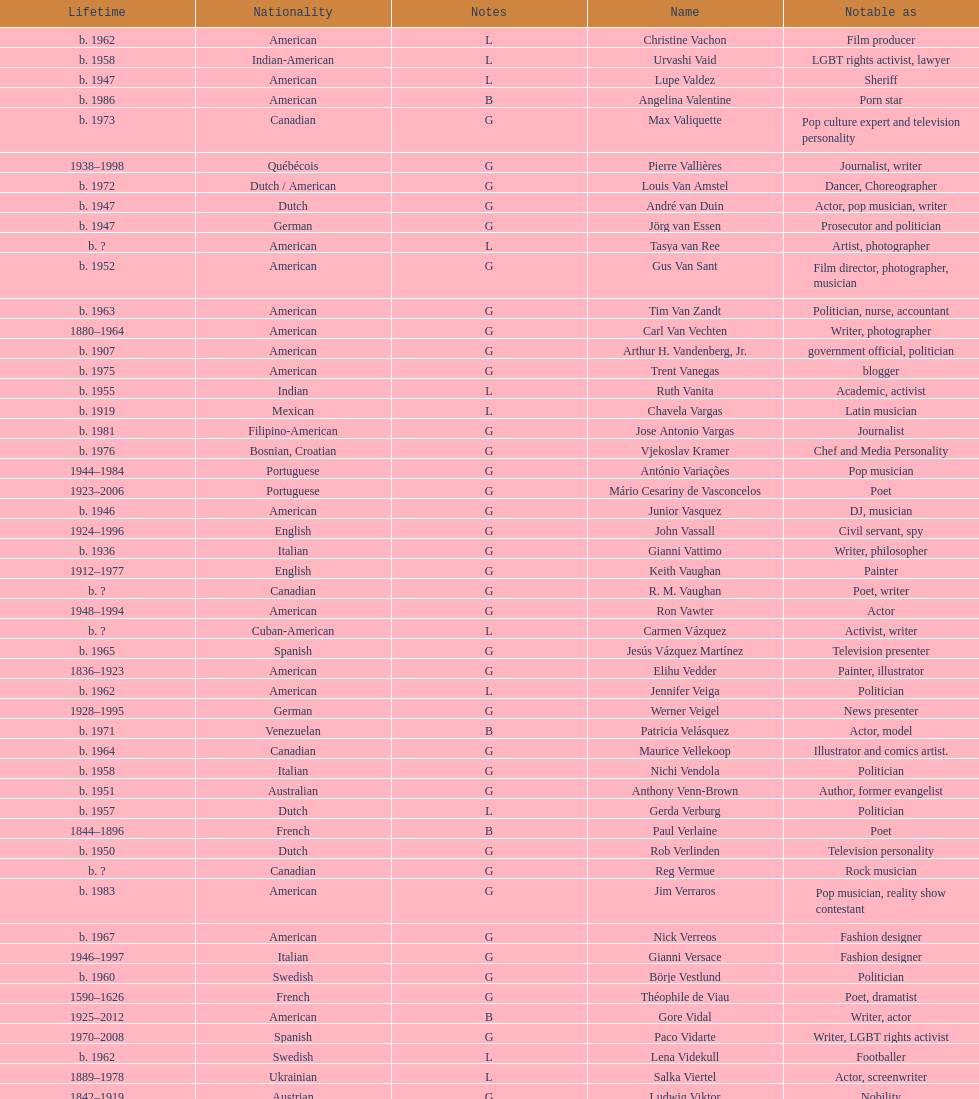Which is the previous name from lupe valdez Urvashi Vaid. 